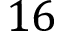Convert formula to latex. <formula><loc_0><loc_0><loc_500><loc_500>1 6</formula> 